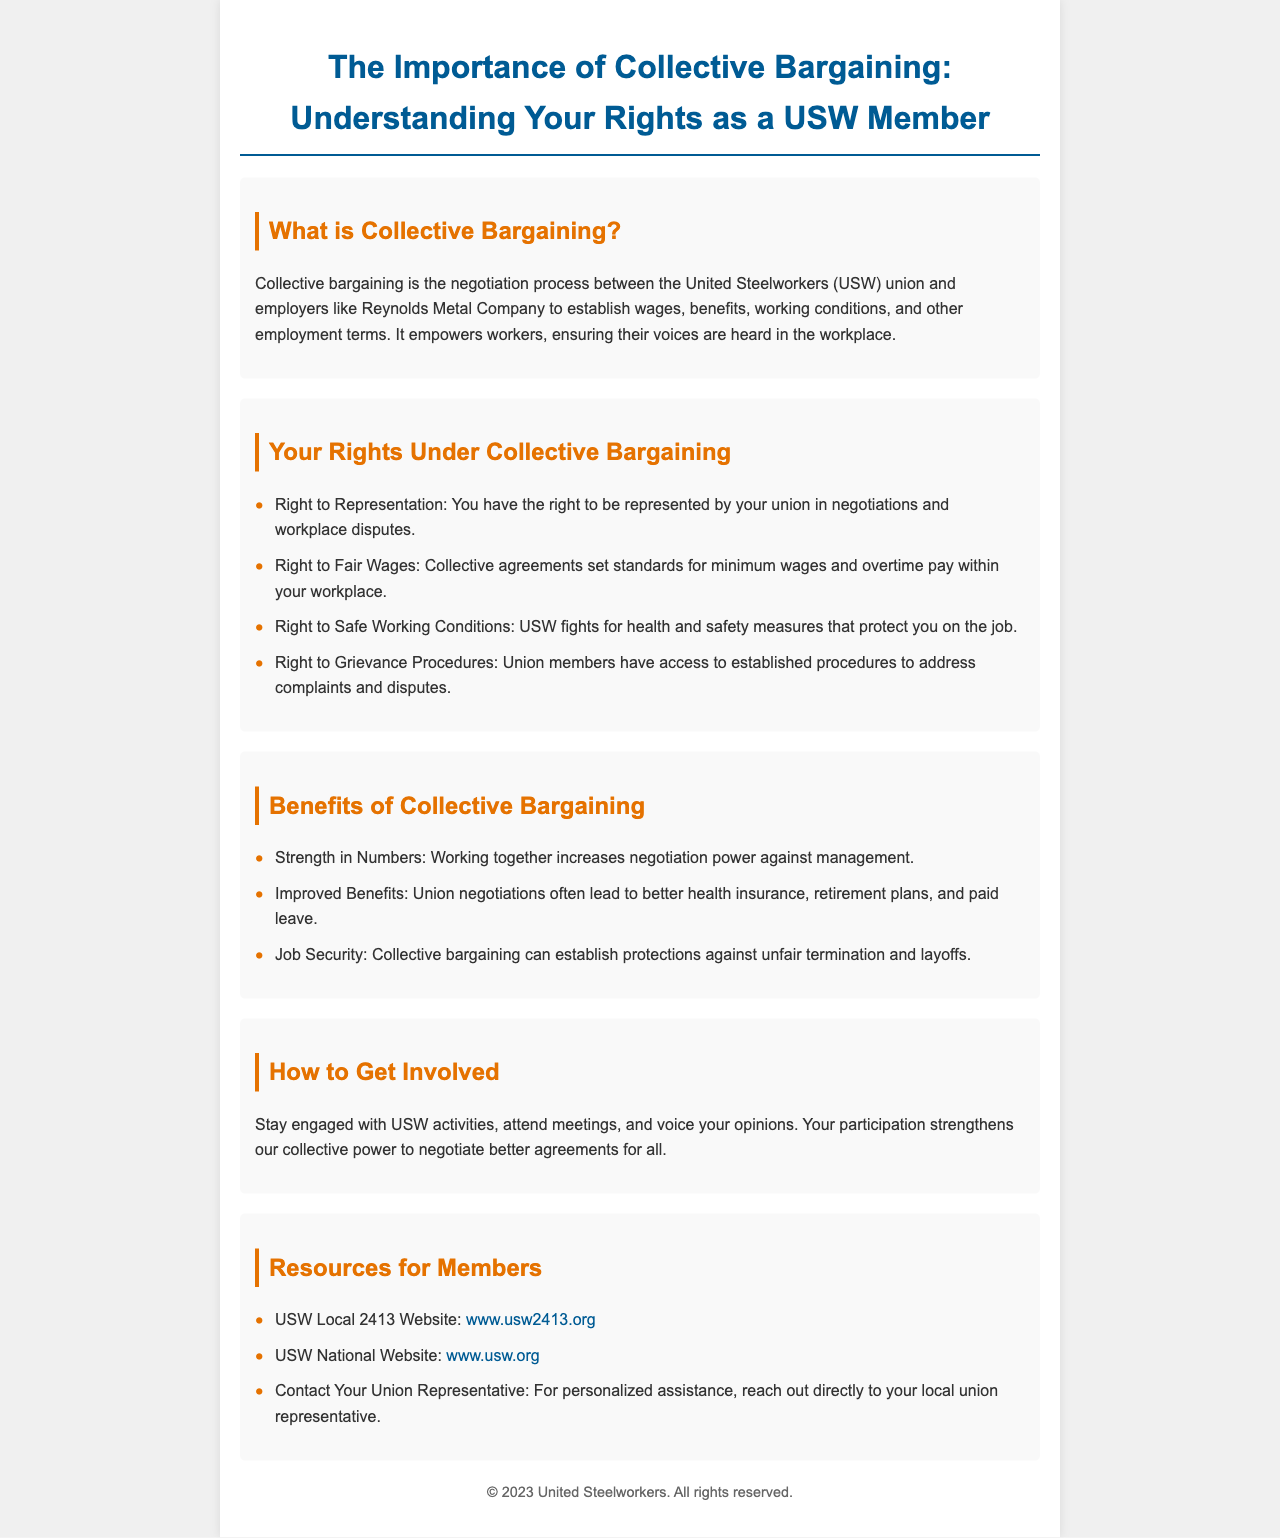What is collective bargaining? Collective bargaining is defined in the document as the negotiation process between the United Steelworkers union and employers to establish wages, benefits, working conditions, and other employment terms.
Answer: The negotiation process What are the rights under collective bargaining? The document lists several rights under collective bargaining, including representation, fair wages, safe working conditions, and grievance procedures.
Answer: Right to Representation What benefit does collective bargaining provide regarding job security? The brochure indicates that collective bargaining can establish protections against unfair termination and layoffs, highlighting job security.
Answer: Protections against unfair termination How can members get involved with the USW? The document suggests that members can stay engaged with USW activities, attend meetings, and voice their opinions as ways to get involved.
Answer: Stay engaged with USW activities What is the website for USW Local 2413? The brochure provides a specific link for USW Local 2413, which can be found in the resources section of the document.
Answer: www.usw2413.org What color is the title of the brochure? The document describes the title of the brochure having a specific color in its styling section, which is part of the design choices made for visual appeal.
Answer: #005b94 What does USW fight for regarding safety? The document states that USW fights for health and safety measures, which is an important aspect of workers' rights under collective bargaining.
Answer: Health and safety measures What is stated about the strength in numbers regarding collective bargaining? The brochure mentions that working together increases negotiation power against management, emphasizing the importance of solidarity.
Answer: Increases negotiation power What is the purpose of grievance procedures mentioned in the document? Grievance procedures provide union members access to established methods for addressing complaints and disputes, which is crucial in workplace agreements.
Answer: Address complaints and disputes 